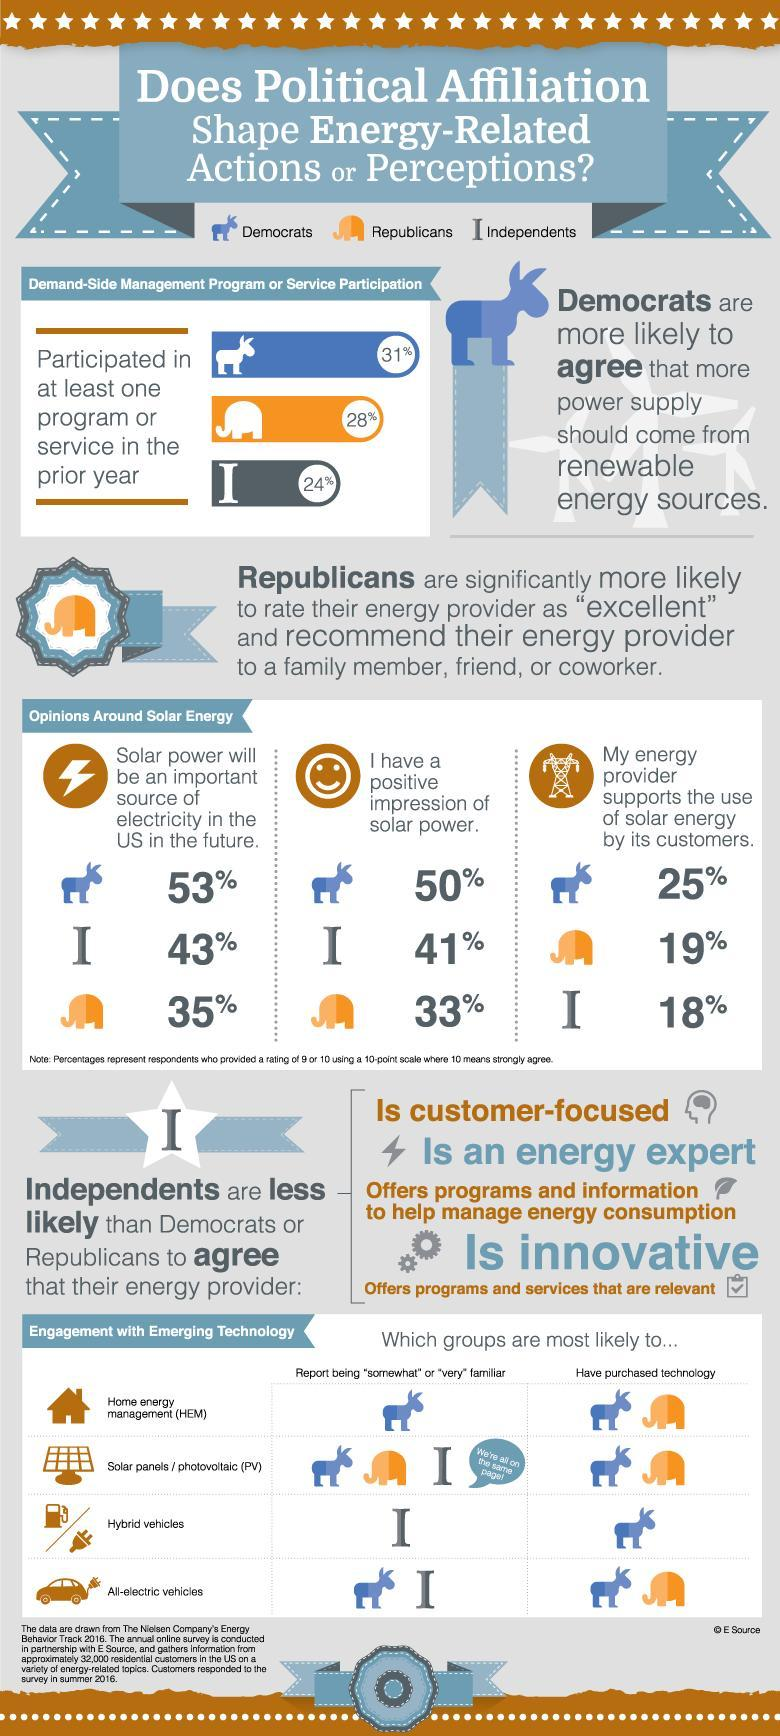What percentage of Republicans feel that solar power will be the source of electricity in the future?
Answer the question with a short phrase. 35% Which groups had mostly purchased solar panels and all-electric vehicles? Democrats, Republicans Which concept was familiar amongst Republicans, Democrats, and Independents? and Solar panels What percentage of Democrats have a positive impression of solar power? 50% Which group is  familiar with the concept of home energy management? Democrats What percentage of Independents participated in demand side management program or service in the prior year? 24% 